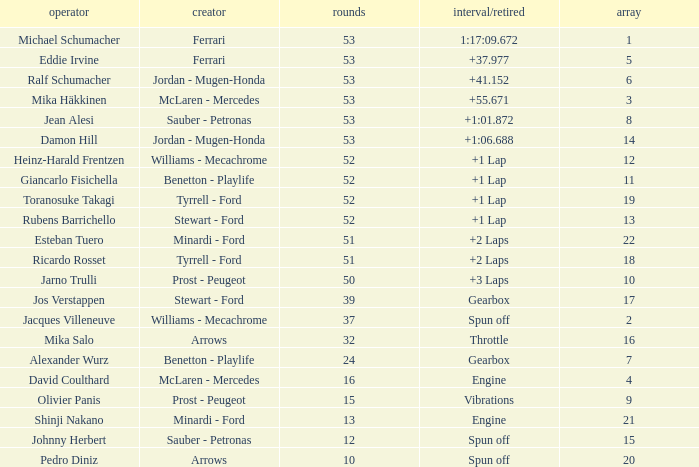Who built the car that went 53 laps with a Time/Retired of 1:17:09.672? Ferrari. 